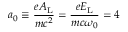Convert formula to latex. <formula><loc_0><loc_0><loc_500><loc_500>a _ { 0 } \equiv \frac { e A _ { L } } { m c ^ { 2 } } = \frac { e E _ { L } } { m c \omega _ { 0 } } = 4</formula> 